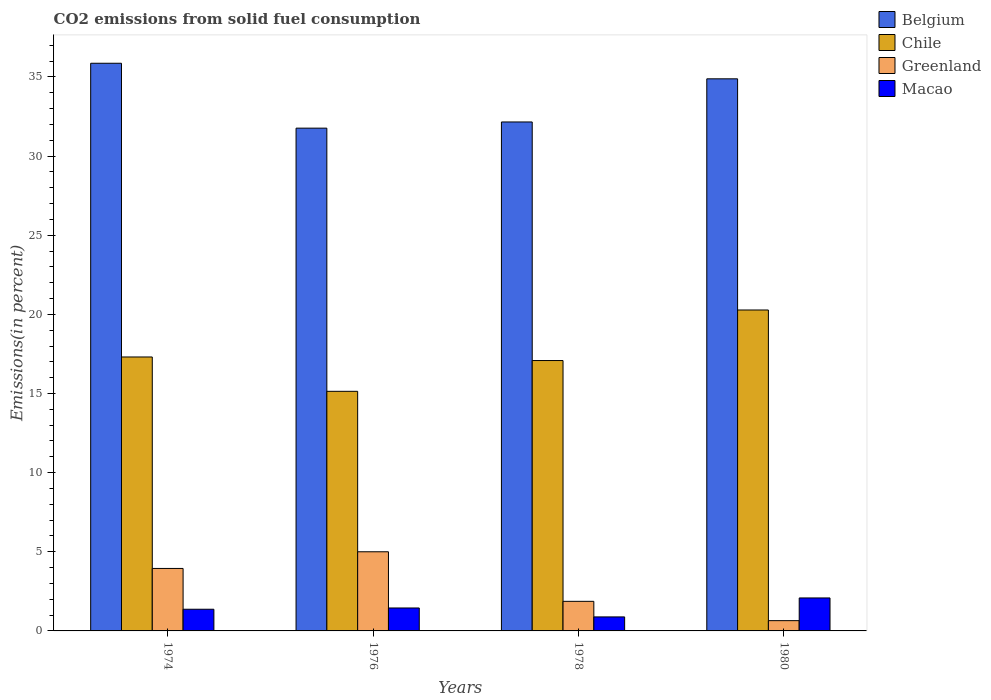How many different coloured bars are there?
Provide a short and direct response. 4. How many groups of bars are there?
Keep it short and to the point. 4. Are the number of bars per tick equal to the number of legend labels?
Keep it short and to the point. Yes. How many bars are there on the 4th tick from the left?
Offer a terse response. 4. In how many cases, is the number of bars for a given year not equal to the number of legend labels?
Offer a terse response. 0. What is the total CO2 emitted in Greenland in 1974?
Ensure brevity in your answer.  3.95. Across all years, what is the maximum total CO2 emitted in Macao?
Provide a succinct answer. 2.08. Across all years, what is the minimum total CO2 emitted in Belgium?
Offer a very short reply. 31.77. In which year was the total CO2 emitted in Belgium minimum?
Offer a terse response. 1976. What is the total total CO2 emitted in Belgium in the graph?
Keep it short and to the point. 134.67. What is the difference between the total CO2 emitted in Greenland in 1974 and that in 1976?
Provide a succinct answer. -1.05. What is the difference between the total CO2 emitted in Chile in 1976 and the total CO2 emitted in Belgium in 1978?
Ensure brevity in your answer.  -17.02. What is the average total CO2 emitted in Chile per year?
Offer a very short reply. 17.45. In the year 1976, what is the difference between the total CO2 emitted in Macao and total CO2 emitted in Belgium?
Offer a terse response. -30.32. What is the ratio of the total CO2 emitted in Greenland in 1974 to that in 1976?
Provide a short and direct response. 0.79. Is the total CO2 emitted in Belgium in 1976 less than that in 1980?
Make the answer very short. Yes. What is the difference between the highest and the second highest total CO2 emitted in Greenland?
Keep it short and to the point. 1.05. What is the difference between the highest and the lowest total CO2 emitted in Belgium?
Provide a short and direct response. 4.1. In how many years, is the total CO2 emitted in Macao greater than the average total CO2 emitted in Macao taken over all years?
Offer a very short reply. 2. Is the sum of the total CO2 emitted in Chile in 1974 and 1980 greater than the maximum total CO2 emitted in Greenland across all years?
Keep it short and to the point. Yes. Is it the case that in every year, the sum of the total CO2 emitted in Belgium and total CO2 emitted in Chile is greater than the sum of total CO2 emitted in Macao and total CO2 emitted in Greenland?
Make the answer very short. No. What does the 3rd bar from the left in 1978 represents?
Ensure brevity in your answer.  Greenland. What does the 3rd bar from the right in 1976 represents?
Provide a short and direct response. Chile. Is it the case that in every year, the sum of the total CO2 emitted in Greenland and total CO2 emitted in Belgium is greater than the total CO2 emitted in Chile?
Your response must be concise. Yes. How many bars are there?
Offer a terse response. 16. Are all the bars in the graph horizontal?
Ensure brevity in your answer.  No. How many years are there in the graph?
Offer a terse response. 4. What is the difference between two consecutive major ticks on the Y-axis?
Provide a short and direct response. 5. Does the graph contain grids?
Provide a short and direct response. No. Where does the legend appear in the graph?
Keep it short and to the point. Top right. How are the legend labels stacked?
Make the answer very short. Vertical. What is the title of the graph?
Keep it short and to the point. CO2 emissions from solid fuel consumption. What is the label or title of the Y-axis?
Keep it short and to the point. Emissions(in percent). What is the Emissions(in percent) in Belgium in 1974?
Offer a terse response. 35.86. What is the Emissions(in percent) in Chile in 1974?
Offer a terse response. 17.31. What is the Emissions(in percent) of Greenland in 1974?
Offer a terse response. 3.95. What is the Emissions(in percent) in Macao in 1974?
Offer a terse response. 1.37. What is the Emissions(in percent) in Belgium in 1976?
Ensure brevity in your answer.  31.77. What is the Emissions(in percent) in Chile in 1976?
Offer a terse response. 15.14. What is the Emissions(in percent) in Macao in 1976?
Provide a short and direct response. 1.45. What is the Emissions(in percent) in Belgium in 1978?
Offer a very short reply. 32.16. What is the Emissions(in percent) in Chile in 1978?
Offer a terse response. 17.08. What is the Emissions(in percent) of Greenland in 1978?
Your answer should be very brief. 1.87. What is the Emissions(in percent) in Macao in 1978?
Give a very brief answer. 0.88. What is the Emissions(in percent) of Belgium in 1980?
Your answer should be very brief. 34.88. What is the Emissions(in percent) of Chile in 1980?
Provide a short and direct response. 20.28. What is the Emissions(in percent) in Greenland in 1980?
Offer a terse response. 0.65. What is the Emissions(in percent) in Macao in 1980?
Ensure brevity in your answer.  2.08. Across all years, what is the maximum Emissions(in percent) of Belgium?
Offer a very short reply. 35.86. Across all years, what is the maximum Emissions(in percent) of Chile?
Keep it short and to the point. 20.28. Across all years, what is the maximum Emissions(in percent) in Macao?
Your answer should be very brief. 2.08. Across all years, what is the minimum Emissions(in percent) in Belgium?
Your answer should be compact. 31.77. Across all years, what is the minimum Emissions(in percent) of Chile?
Your answer should be very brief. 15.14. Across all years, what is the minimum Emissions(in percent) of Greenland?
Give a very brief answer. 0.65. Across all years, what is the minimum Emissions(in percent) of Macao?
Your response must be concise. 0.88. What is the total Emissions(in percent) in Belgium in the graph?
Your answer should be compact. 134.67. What is the total Emissions(in percent) in Chile in the graph?
Your response must be concise. 69.8. What is the total Emissions(in percent) of Greenland in the graph?
Your answer should be compact. 11.47. What is the total Emissions(in percent) in Macao in the graph?
Your answer should be compact. 5.79. What is the difference between the Emissions(in percent) in Belgium in 1974 and that in 1976?
Offer a terse response. 4.1. What is the difference between the Emissions(in percent) in Chile in 1974 and that in 1976?
Provide a succinct answer. 2.17. What is the difference between the Emissions(in percent) in Greenland in 1974 and that in 1976?
Your answer should be very brief. -1.05. What is the difference between the Emissions(in percent) in Macao in 1974 and that in 1976?
Provide a succinct answer. -0.08. What is the difference between the Emissions(in percent) in Belgium in 1974 and that in 1978?
Your response must be concise. 3.71. What is the difference between the Emissions(in percent) in Chile in 1974 and that in 1978?
Keep it short and to the point. 0.23. What is the difference between the Emissions(in percent) in Greenland in 1974 and that in 1978?
Give a very brief answer. 2.08. What is the difference between the Emissions(in percent) in Macao in 1974 and that in 1978?
Make the answer very short. 0.48. What is the difference between the Emissions(in percent) in Belgium in 1974 and that in 1980?
Your answer should be compact. 0.98. What is the difference between the Emissions(in percent) in Chile in 1974 and that in 1980?
Ensure brevity in your answer.  -2.97. What is the difference between the Emissions(in percent) in Greenland in 1974 and that in 1980?
Your answer should be compact. 3.3. What is the difference between the Emissions(in percent) in Macao in 1974 and that in 1980?
Provide a short and direct response. -0.71. What is the difference between the Emissions(in percent) of Belgium in 1976 and that in 1978?
Provide a succinct answer. -0.39. What is the difference between the Emissions(in percent) of Chile in 1976 and that in 1978?
Make the answer very short. -1.94. What is the difference between the Emissions(in percent) of Greenland in 1976 and that in 1978?
Offer a terse response. 3.13. What is the difference between the Emissions(in percent) of Macao in 1976 and that in 1978?
Offer a very short reply. 0.56. What is the difference between the Emissions(in percent) in Belgium in 1976 and that in 1980?
Provide a succinct answer. -3.12. What is the difference between the Emissions(in percent) in Chile in 1976 and that in 1980?
Your answer should be compact. -5.14. What is the difference between the Emissions(in percent) of Greenland in 1976 and that in 1980?
Make the answer very short. 4.35. What is the difference between the Emissions(in percent) of Macao in 1976 and that in 1980?
Offer a terse response. -0.63. What is the difference between the Emissions(in percent) of Belgium in 1978 and that in 1980?
Ensure brevity in your answer.  -2.73. What is the difference between the Emissions(in percent) in Chile in 1978 and that in 1980?
Provide a succinct answer. -3.19. What is the difference between the Emissions(in percent) in Greenland in 1978 and that in 1980?
Offer a very short reply. 1.22. What is the difference between the Emissions(in percent) in Macao in 1978 and that in 1980?
Give a very brief answer. -1.2. What is the difference between the Emissions(in percent) in Belgium in 1974 and the Emissions(in percent) in Chile in 1976?
Your answer should be compact. 20.73. What is the difference between the Emissions(in percent) of Belgium in 1974 and the Emissions(in percent) of Greenland in 1976?
Make the answer very short. 30.86. What is the difference between the Emissions(in percent) in Belgium in 1974 and the Emissions(in percent) in Macao in 1976?
Provide a short and direct response. 34.42. What is the difference between the Emissions(in percent) in Chile in 1974 and the Emissions(in percent) in Greenland in 1976?
Your response must be concise. 12.31. What is the difference between the Emissions(in percent) of Chile in 1974 and the Emissions(in percent) of Macao in 1976?
Make the answer very short. 15.86. What is the difference between the Emissions(in percent) in Greenland in 1974 and the Emissions(in percent) in Macao in 1976?
Ensure brevity in your answer.  2.5. What is the difference between the Emissions(in percent) of Belgium in 1974 and the Emissions(in percent) of Chile in 1978?
Make the answer very short. 18.78. What is the difference between the Emissions(in percent) in Belgium in 1974 and the Emissions(in percent) in Greenland in 1978?
Make the answer very short. 34. What is the difference between the Emissions(in percent) of Belgium in 1974 and the Emissions(in percent) of Macao in 1978?
Offer a very short reply. 34.98. What is the difference between the Emissions(in percent) in Chile in 1974 and the Emissions(in percent) in Greenland in 1978?
Provide a short and direct response. 15.44. What is the difference between the Emissions(in percent) in Chile in 1974 and the Emissions(in percent) in Macao in 1978?
Offer a very short reply. 16.42. What is the difference between the Emissions(in percent) of Greenland in 1974 and the Emissions(in percent) of Macao in 1978?
Give a very brief answer. 3.06. What is the difference between the Emissions(in percent) of Belgium in 1974 and the Emissions(in percent) of Chile in 1980?
Provide a short and direct response. 15.59. What is the difference between the Emissions(in percent) in Belgium in 1974 and the Emissions(in percent) in Greenland in 1980?
Offer a terse response. 35.22. What is the difference between the Emissions(in percent) in Belgium in 1974 and the Emissions(in percent) in Macao in 1980?
Provide a short and direct response. 33.78. What is the difference between the Emissions(in percent) of Chile in 1974 and the Emissions(in percent) of Greenland in 1980?
Provide a succinct answer. 16.66. What is the difference between the Emissions(in percent) of Chile in 1974 and the Emissions(in percent) of Macao in 1980?
Your answer should be very brief. 15.22. What is the difference between the Emissions(in percent) in Greenland in 1974 and the Emissions(in percent) in Macao in 1980?
Your answer should be very brief. 1.86. What is the difference between the Emissions(in percent) of Belgium in 1976 and the Emissions(in percent) of Chile in 1978?
Ensure brevity in your answer.  14.68. What is the difference between the Emissions(in percent) of Belgium in 1976 and the Emissions(in percent) of Greenland in 1978?
Make the answer very short. 29.9. What is the difference between the Emissions(in percent) in Belgium in 1976 and the Emissions(in percent) in Macao in 1978?
Your response must be concise. 30.88. What is the difference between the Emissions(in percent) in Chile in 1976 and the Emissions(in percent) in Greenland in 1978?
Your answer should be very brief. 13.27. What is the difference between the Emissions(in percent) of Chile in 1976 and the Emissions(in percent) of Macao in 1978?
Your answer should be very brief. 14.25. What is the difference between the Emissions(in percent) of Greenland in 1976 and the Emissions(in percent) of Macao in 1978?
Ensure brevity in your answer.  4.12. What is the difference between the Emissions(in percent) in Belgium in 1976 and the Emissions(in percent) in Chile in 1980?
Give a very brief answer. 11.49. What is the difference between the Emissions(in percent) in Belgium in 1976 and the Emissions(in percent) in Greenland in 1980?
Make the answer very short. 31.12. What is the difference between the Emissions(in percent) in Belgium in 1976 and the Emissions(in percent) in Macao in 1980?
Keep it short and to the point. 29.68. What is the difference between the Emissions(in percent) in Chile in 1976 and the Emissions(in percent) in Greenland in 1980?
Offer a very short reply. 14.49. What is the difference between the Emissions(in percent) in Chile in 1976 and the Emissions(in percent) in Macao in 1980?
Keep it short and to the point. 13.05. What is the difference between the Emissions(in percent) in Greenland in 1976 and the Emissions(in percent) in Macao in 1980?
Give a very brief answer. 2.92. What is the difference between the Emissions(in percent) of Belgium in 1978 and the Emissions(in percent) of Chile in 1980?
Your response must be concise. 11.88. What is the difference between the Emissions(in percent) of Belgium in 1978 and the Emissions(in percent) of Greenland in 1980?
Your response must be concise. 31.51. What is the difference between the Emissions(in percent) in Belgium in 1978 and the Emissions(in percent) in Macao in 1980?
Keep it short and to the point. 30.07. What is the difference between the Emissions(in percent) of Chile in 1978 and the Emissions(in percent) of Greenland in 1980?
Provide a short and direct response. 16.43. What is the difference between the Emissions(in percent) in Chile in 1978 and the Emissions(in percent) in Macao in 1980?
Give a very brief answer. 15. What is the difference between the Emissions(in percent) of Greenland in 1978 and the Emissions(in percent) of Macao in 1980?
Your response must be concise. -0.21. What is the average Emissions(in percent) in Belgium per year?
Keep it short and to the point. 33.67. What is the average Emissions(in percent) of Chile per year?
Provide a short and direct response. 17.45. What is the average Emissions(in percent) in Greenland per year?
Your answer should be compact. 2.87. What is the average Emissions(in percent) in Macao per year?
Your answer should be compact. 1.45. In the year 1974, what is the difference between the Emissions(in percent) in Belgium and Emissions(in percent) in Chile?
Your answer should be very brief. 18.56. In the year 1974, what is the difference between the Emissions(in percent) in Belgium and Emissions(in percent) in Greenland?
Give a very brief answer. 31.92. In the year 1974, what is the difference between the Emissions(in percent) in Belgium and Emissions(in percent) in Macao?
Make the answer very short. 34.49. In the year 1974, what is the difference between the Emissions(in percent) in Chile and Emissions(in percent) in Greenland?
Provide a succinct answer. 13.36. In the year 1974, what is the difference between the Emissions(in percent) in Chile and Emissions(in percent) in Macao?
Your response must be concise. 15.94. In the year 1974, what is the difference between the Emissions(in percent) in Greenland and Emissions(in percent) in Macao?
Give a very brief answer. 2.58. In the year 1976, what is the difference between the Emissions(in percent) of Belgium and Emissions(in percent) of Chile?
Offer a terse response. 16.63. In the year 1976, what is the difference between the Emissions(in percent) of Belgium and Emissions(in percent) of Greenland?
Provide a succinct answer. 26.77. In the year 1976, what is the difference between the Emissions(in percent) in Belgium and Emissions(in percent) in Macao?
Your response must be concise. 30.32. In the year 1976, what is the difference between the Emissions(in percent) of Chile and Emissions(in percent) of Greenland?
Make the answer very short. 10.14. In the year 1976, what is the difference between the Emissions(in percent) of Chile and Emissions(in percent) of Macao?
Offer a terse response. 13.69. In the year 1976, what is the difference between the Emissions(in percent) in Greenland and Emissions(in percent) in Macao?
Your response must be concise. 3.55. In the year 1978, what is the difference between the Emissions(in percent) in Belgium and Emissions(in percent) in Chile?
Give a very brief answer. 15.07. In the year 1978, what is the difference between the Emissions(in percent) in Belgium and Emissions(in percent) in Greenland?
Make the answer very short. 30.29. In the year 1978, what is the difference between the Emissions(in percent) of Belgium and Emissions(in percent) of Macao?
Your response must be concise. 31.27. In the year 1978, what is the difference between the Emissions(in percent) in Chile and Emissions(in percent) in Greenland?
Ensure brevity in your answer.  15.21. In the year 1978, what is the difference between the Emissions(in percent) of Chile and Emissions(in percent) of Macao?
Give a very brief answer. 16.2. In the year 1978, what is the difference between the Emissions(in percent) of Greenland and Emissions(in percent) of Macao?
Offer a very short reply. 0.98. In the year 1980, what is the difference between the Emissions(in percent) in Belgium and Emissions(in percent) in Chile?
Your answer should be compact. 14.61. In the year 1980, what is the difference between the Emissions(in percent) of Belgium and Emissions(in percent) of Greenland?
Ensure brevity in your answer.  34.23. In the year 1980, what is the difference between the Emissions(in percent) of Belgium and Emissions(in percent) of Macao?
Ensure brevity in your answer.  32.8. In the year 1980, what is the difference between the Emissions(in percent) in Chile and Emissions(in percent) in Greenland?
Ensure brevity in your answer.  19.63. In the year 1980, what is the difference between the Emissions(in percent) of Chile and Emissions(in percent) of Macao?
Provide a succinct answer. 18.19. In the year 1980, what is the difference between the Emissions(in percent) in Greenland and Emissions(in percent) in Macao?
Make the answer very short. -1.43. What is the ratio of the Emissions(in percent) in Belgium in 1974 to that in 1976?
Your answer should be very brief. 1.13. What is the ratio of the Emissions(in percent) in Chile in 1974 to that in 1976?
Provide a short and direct response. 1.14. What is the ratio of the Emissions(in percent) in Greenland in 1974 to that in 1976?
Ensure brevity in your answer.  0.79. What is the ratio of the Emissions(in percent) in Macao in 1974 to that in 1976?
Keep it short and to the point. 0.95. What is the ratio of the Emissions(in percent) in Belgium in 1974 to that in 1978?
Your answer should be compact. 1.12. What is the ratio of the Emissions(in percent) of Chile in 1974 to that in 1978?
Your response must be concise. 1.01. What is the ratio of the Emissions(in percent) of Greenland in 1974 to that in 1978?
Make the answer very short. 2.11. What is the ratio of the Emissions(in percent) of Macao in 1974 to that in 1978?
Give a very brief answer. 1.55. What is the ratio of the Emissions(in percent) of Belgium in 1974 to that in 1980?
Your answer should be compact. 1.03. What is the ratio of the Emissions(in percent) in Chile in 1974 to that in 1980?
Your response must be concise. 0.85. What is the ratio of the Emissions(in percent) in Greenland in 1974 to that in 1980?
Your response must be concise. 6.08. What is the ratio of the Emissions(in percent) of Macao in 1974 to that in 1980?
Your answer should be compact. 0.66. What is the ratio of the Emissions(in percent) of Belgium in 1976 to that in 1978?
Provide a succinct answer. 0.99. What is the ratio of the Emissions(in percent) of Chile in 1976 to that in 1978?
Offer a terse response. 0.89. What is the ratio of the Emissions(in percent) in Greenland in 1976 to that in 1978?
Your response must be concise. 2.67. What is the ratio of the Emissions(in percent) in Macao in 1976 to that in 1978?
Your answer should be very brief. 1.64. What is the ratio of the Emissions(in percent) of Belgium in 1976 to that in 1980?
Your answer should be compact. 0.91. What is the ratio of the Emissions(in percent) in Chile in 1976 to that in 1980?
Your response must be concise. 0.75. What is the ratio of the Emissions(in percent) in Greenland in 1976 to that in 1980?
Keep it short and to the point. 7.7. What is the ratio of the Emissions(in percent) in Macao in 1976 to that in 1980?
Offer a terse response. 0.7. What is the ratio of the Emissions(in percent) in Belgium in 1978 to that in 1980?
Provide a short and direct response. 0.92. What is the ratio of the Emissions(in percent) in Chile in 1978 to that in 1980?
Provide a succinct answer. 0.84. What is the ratio of the Emissions(in percent) in Greenland in 1978 to that in 1980?
Give a very brief answer. 2.88. What is the ratio of the Emissions(in percent) of Macao in 1978 to that in 1980?
Your answer should be very brief. 0.42. What is the difference between the highest and the second highest Emissions(in percent) in Belgium?
Offer a very short reply. 0.98. What is the difference between the highest and the second highest Emissions(in percent) of Chile?
Keep it short and to the point. 2.97. What is the difference between the highest and the second highest Emissions(in percent) of Greenland?
Your answer should be very brief. 1.05. What is the difference between the highest and the second highest Emissions(in percent) of Macao?
Keep it short and to the point. 0.63. What is the difference between the highest and the lowest Emissions(in percent) of Belgium?
Offer a terse response. 4.1. What is the difference between the highest and the lowest Emissions(in percent) in Chile?
Your answer should be very brief. 5.14. What is the difference between the highest and the lowest Emissions(in percent) of Greenland?
Make the answer very short. 4.35. What is the difference between the highest and the lowest Emissions(in percent) in Macao?
Ensure brevity in your answer.  1.2. 